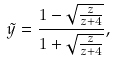<formula> <loc_0><loc_0><loc_500><loc_500>\tilde { y } = \frac { 1 - \sqrt { \frac { z } { z + 4 } } } { 1 + \sqrt { \frac { z } { z + 4 } } } ,</formula> 